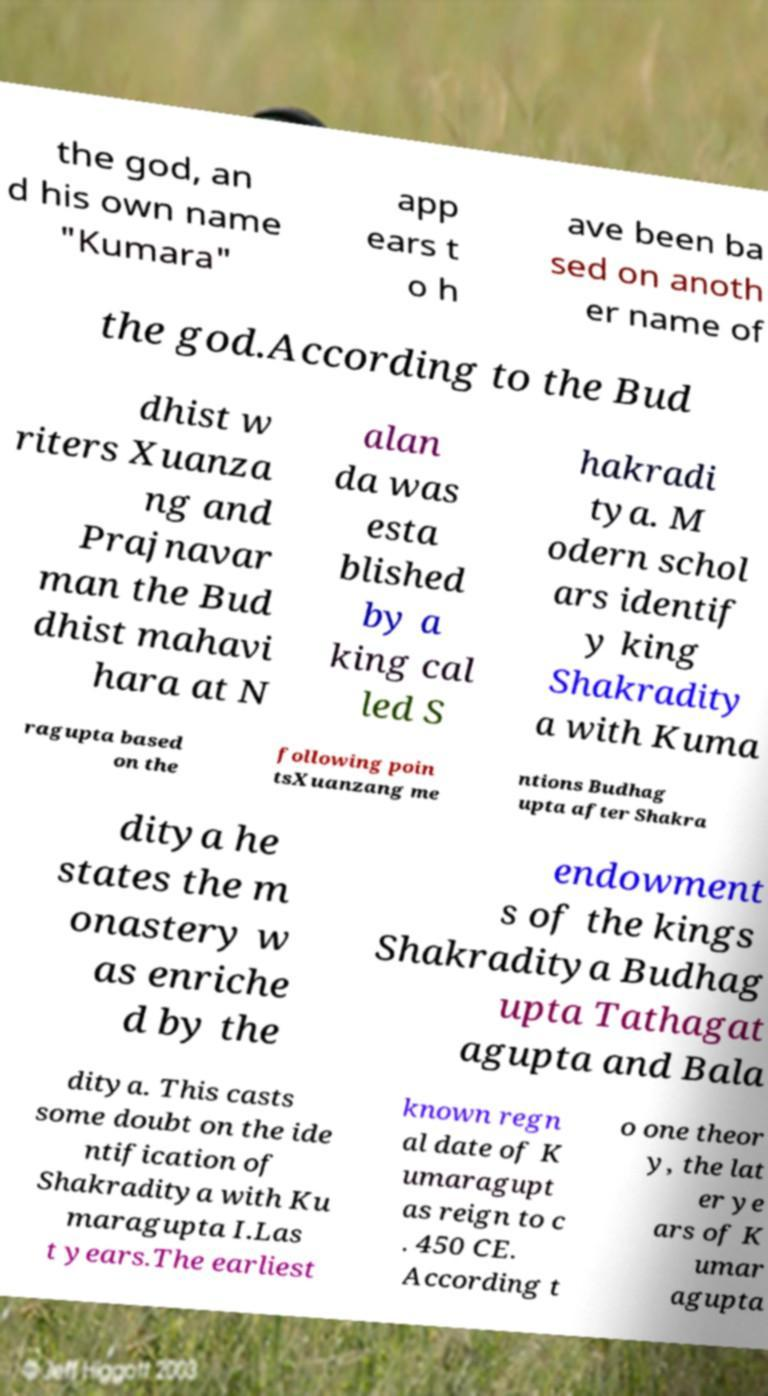Could you assist in decoding the text presented in this image and type it out clearly? the god, an d his own name "Kumara" app ears t o h ave been ba sed on anoth er name of the god.According to the Bud dhist w riters Xuanza ng and Prajnavar man the Bud dhist mahavi hara at N alan da was esta blished by a king cal led S hakradi tya. M odern schol ars identif y king Shakradity a with Kuma ragupta based on the following poin tsXuanzang me ntions Budhag upta after Shakra ditya he states the m onastery w as enriche d by the endowment s of the kings Shakraditya Budhag upta Tathagat agupta and Bala ditya. This casts some doubt on the ide ntification of Shakraditya with Ku maragupta I.Las t years.The earliest known regn al date of K umaragupt as reign to c . 450 CE. According t o one theor y, the lat er ye ars of K umar agupta 